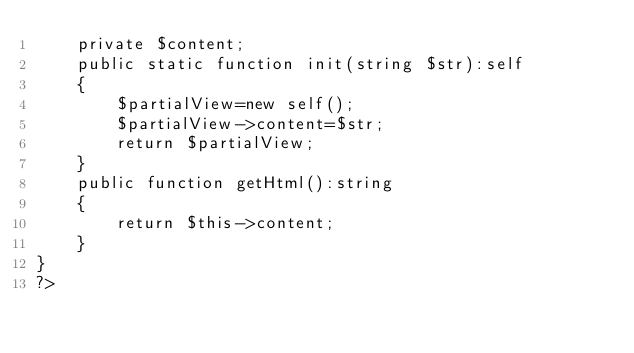Convert code to text. <code><loc_0><loc_0><loc_500><loc_500><_PHP_>	private $content;
	public static function init(string $str):self
	{
		$partialView=new self();
		$partialView->content=$str;
        return $partialView;
	}
	public function getHtml():string
	{
		return $this->content;
	}
}
?></code> 